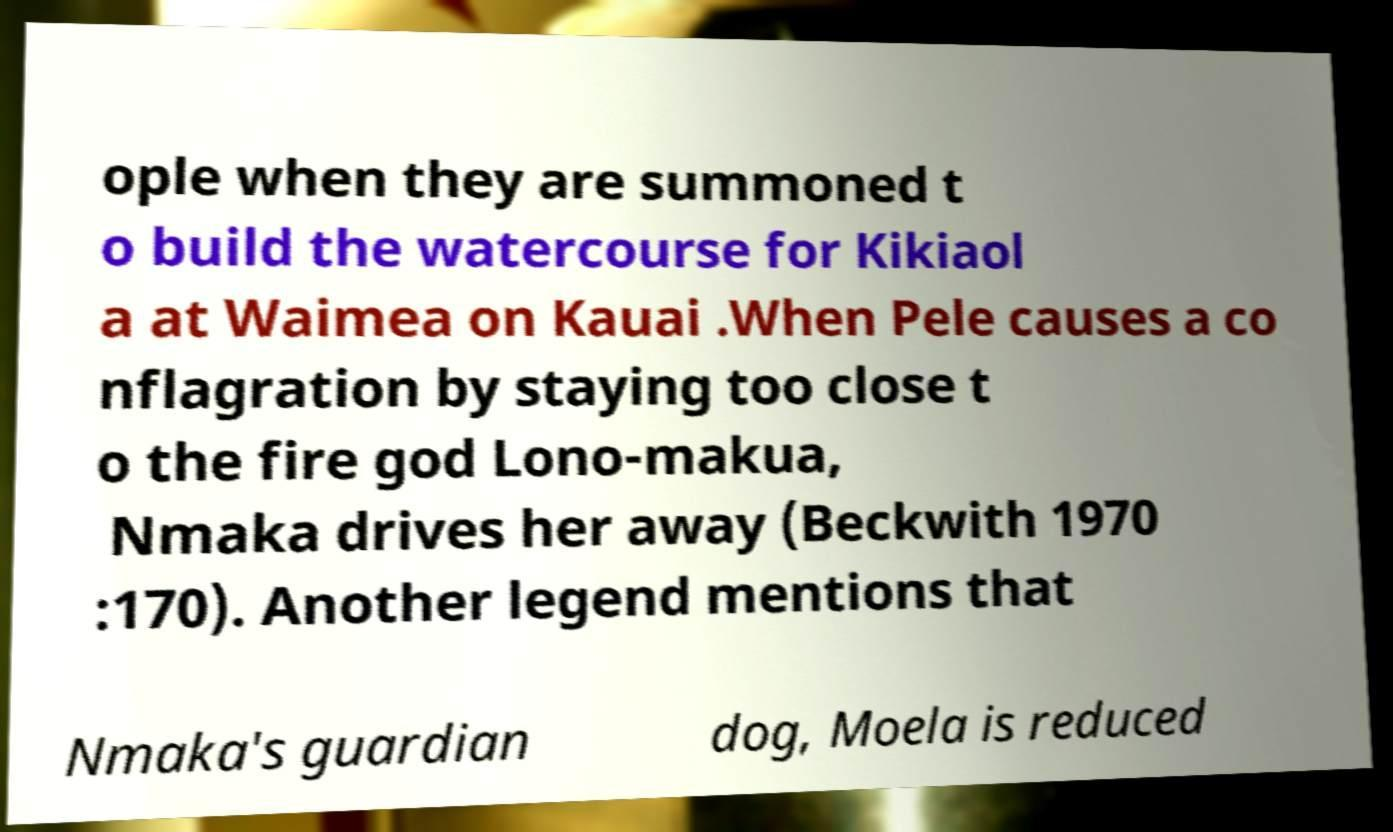Could you extract and type out the text from this image? ople when they are summoned t o build the watercourse for Kikiaol a at Waimea on Kauai .When Pele causes a co nflagration by staying too close t o the fire god Lono-makua, Nmaka drives her away (Beckwith 1970 :170). Another legend mentions that Nmaka's guardian dog, Moela is reduced 